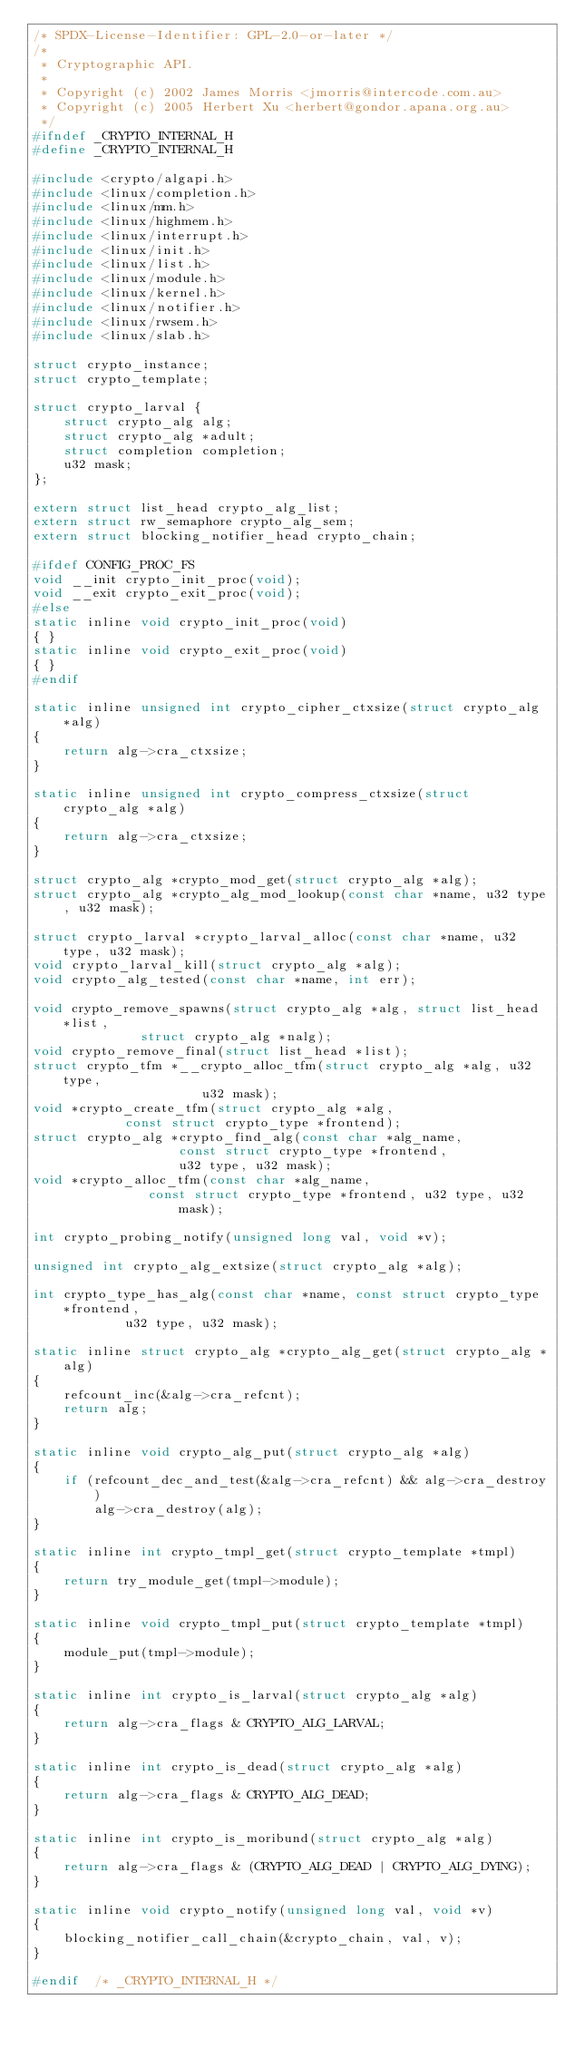<code> <loc_0><loc_0><loc_500><loc_500><_C_>/* SPDX-License-Identifier: GPL-2.0-or-later */
/*
 * Cryptographic API.
 *
 * Copyright (c) 2002 James Morris <jmorris@intercode.com.au>
 * Copyright (c) 2005 Herbert Xu <herbert@gondor.apana.org.au>
 */
#ifndef _CRYPTO_INTERNAL_H
#define _CRYPTO_INTERNAL_H

#include <crypto/algapi.h>
#include <linux/completion.h>
#include <linux/mm.h>
#include <linux/highmem.h>
#include <linux/interrupt.h>
#include <linux/init.h>
#include <linux/list.h>
#include <linux/module.h>
#include <linux/kernel.h>
#include <linux/notifier.h>
#include <linux/rwsem.h>
#include <linux/slab.h>

struct crypto_instance;
struct crypto_template;

struct crypto_larval {
	struct crypto_alg alg;
	struct crypto_alg *adult;
	struct completion completion;
	u32 mask;
};

extern struct list_head crypto_alg_list;
extern struct rw_semaphore crypto_alg_sem;
extern struct blocking_notifier_head crypto_chain;

#ifdef CONFIG_PROC_FS
void __init crypto_init_proc(void);
void __exit crypto_exit_proc(void);
#else
static inline void crypto_init_proc(void)
{ }
static inline void crypto_exit_proc(void)
{ }
#endif

static inline unsigned int crypto_cipher_ctxsize(struct crypto_alg *alg)
{
	return alg->cra_ctxsize;
}

static inline unsigned int crypto_compress_ctxsize(struct crypto_alg *alg)
{
	return alg->cra_ctxsize;
}

struct crypto_alg *crypto_mod_get(struct crypto_alg *alg);
struct crypto_alg *crypto_alg_mod_lookup(const char *name, u32 type, u32 mask);

struct crypto_larval *crypto_larval_alloc(const char *name, u32 type, u32 mask);
void crypto_larval_kill(struct crypto_alg *alg);
void crypto_alg_tested(const char *name, int err);

void crypto_remove_spawns(struct crypto_alg *alg, struct list_head *list,
			  struct crypto_alg *nalg);
void crypto_remove_final(struct list_head *list);
struct crypto_tfm *__crypto_alloc_tfm(struct crypto_alg *alg, u32 type,
				      u32 mask);
void *crypto_create_tfm(struct crypto_alg *alg,
			const struct crypto_type *frontend);
struct crypto_alg *crypto_find_alg(const char *alg_name,
				   const struct crypto_type *frontend,
				   u32 type, u32 mask);
void *crypto_alloc_tfm(const char *alg_name,
		       const struct crypto_type *frontend, u32 type, u32 mask);

int crypto_probing_notify(unsigned long val, void *v);

unsigned int crypto_alg_extsize(struct crypto_alg *alg);

int crypto_type_has_alg(const char *name, const struct crypto_type *frontend,
			u32 type, u32 mask);

static inline struct crypto_alg *crypto_alg_get(struct crypto_alg *alg)
{
	refcount_inc(&alg->cra_refcnt);
	return alg;
}

static inline void crypto_alg_put(struct crypto_alg *alg)
{
	if (refcount_dec_and_test(&alg->cra_refcnt) && alg->cra_destroy)
		alg->cra_destroy(alg);
}

static inline int crypto_tmpl_get(struct crypto_template *tmpl)
{
	return try_module_get(tmpl->module);
}

static inline void crypto_tmpl_put(struct crypto_template *tmpl)
{
	module_put(tmpl->module);
}

static inline int crypto_is_larval(struct crypto_alg *alg)
{
	return alg->cra_flags & CRYPTO_ALG_LARVAL;
}

static inline int crypto_is_dead(struct crypto_alg *alg)
{
	return alg->cra_flags & CRYPTO_ALG_DEAD;
}

static inline int crypto_is_moribund(struct crypto_alg *alg)
{
	return alg->cra_flags & (CRYPTO_ALG_DEAD | CRYPTO_ALG_DYING);
}

static inline void crypto_notify(unsigned long val, void *v)
{
	blocking_notifier_call_chain(&crypto_chain, val, v);
}

#endif	/* _CRYPTO_INTERNAL_H */

</code> 